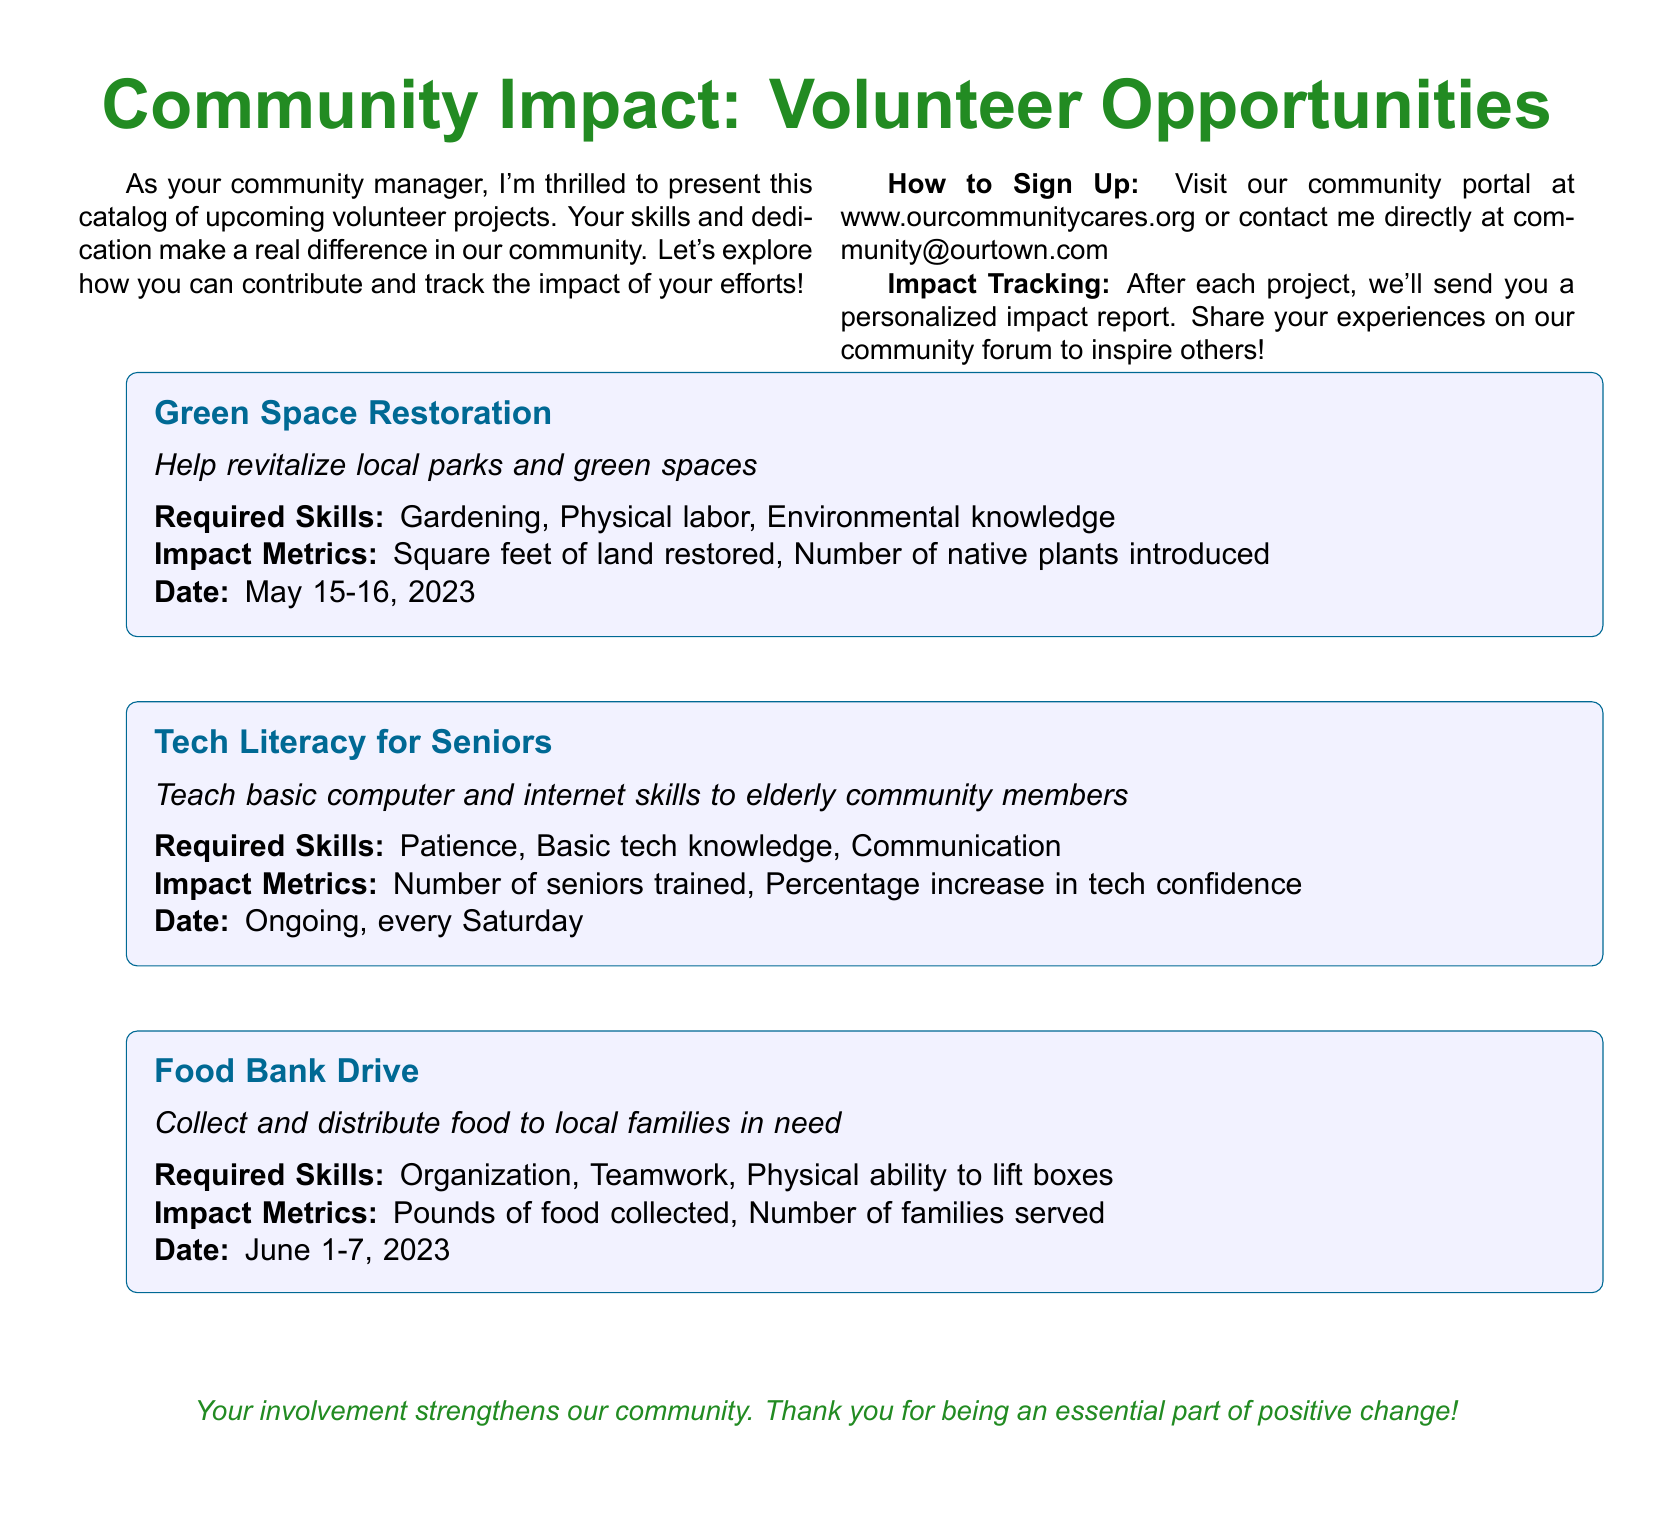What is the title of the first project listed? The title of the first project is explicitly mentioned as "Green Space Restoration" in the document.
Answer: Green Space Restoration What skills are required for the Tech Literacy for Seniors project? The required skills for the Tech Literacy for Seniors project are detailed within the project box and are "Patience, Basic tech knowledge, Communication."
Answer: Patience, Basic tech knowledge, Communication What is the impact metric for the Food Bank Drive? The impact metrics for the Food Bank Drive are indicated in the project details as "Pounds of food collected, Number of families served."
Answer: Pounds of food collected, Number of families served When does the Green Space Restoration project occur? The dates for the Green Space Restoration project are specified within the project box as May 15-16, 2023.
Answer: May 15-16, 2023 How often is the Tech Literacy for Seniors project held? The frequency of the Tech Literacy for Seniors project is stated as "Ongoing, every Saturday" in the document.
Answer: Ongoing, every Saturday What type of volunteer work is the Food Bank Drive associated with? The type of volunteer work related to the Food Bank Drive is described as "Collect and distribute food to local families in need."
Answer: Collect and distribute food How can individuals sign up for volunteer opportunities? Instructions for signing up are given in the closing section of the document, stating to visit the community portal or contact the community manager.
Answer: Visit our community portal or contact me directly What is the color theme used in the document? The document uses a color theme including a specific green and blue identified as "mygreen" and "myblue."
Answer: Mygreen and Myblue What is the main purpose of the catalog? The catalog's primary purpose is introduced as a way for community members to find and engage in volunteer opportunities impacting their community.
Answer: Volunteer opportunities impacting community 